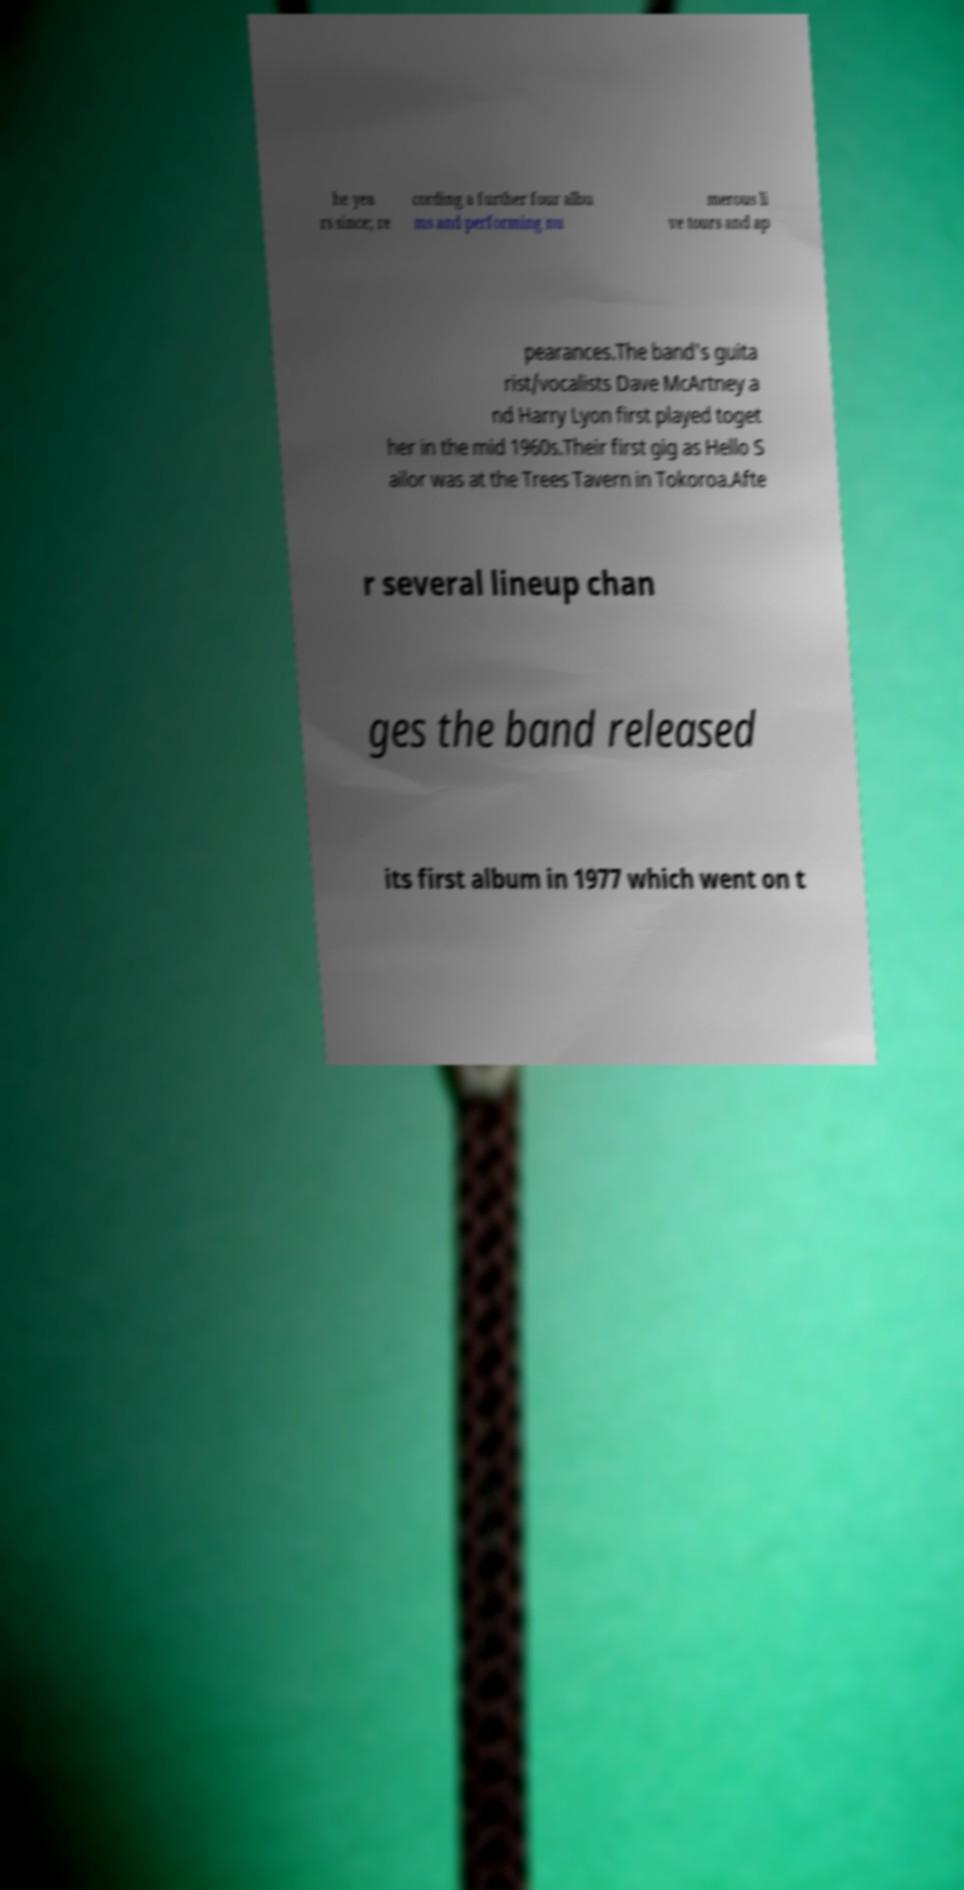Could you assist in decoding the text presented in this image and type it out clearly? he yea rs since; re cording a further four albu ms and performing nu merous li ve tours and ap pearances.The band's guita rist/vocalists Dave McArtney a nd Harry Lyon first played toget her in the mid 1960s.Their first gig as Hello S ailor was at the Trees Tavern in Tokoroa.Afte r several lineup chan ges the band released its first album in 1977 which went on t 